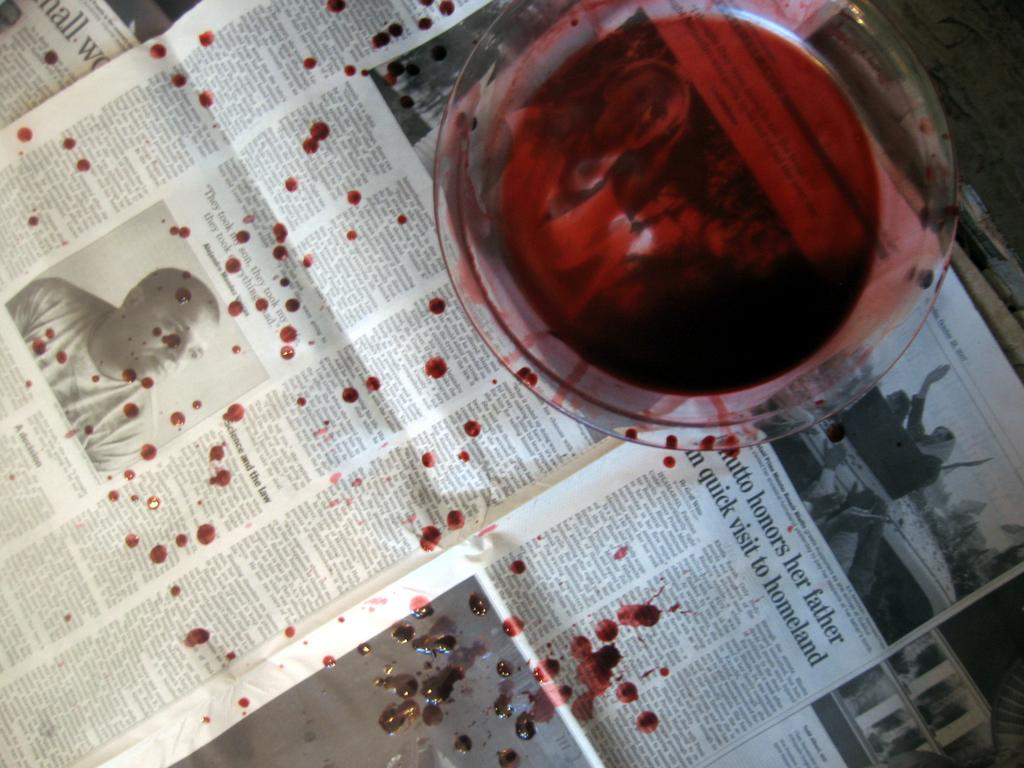<image>
Provide a brief description of the given image. A glass of red liquid is on a liquid splattered newspaper which has a story about president Bhutto. 